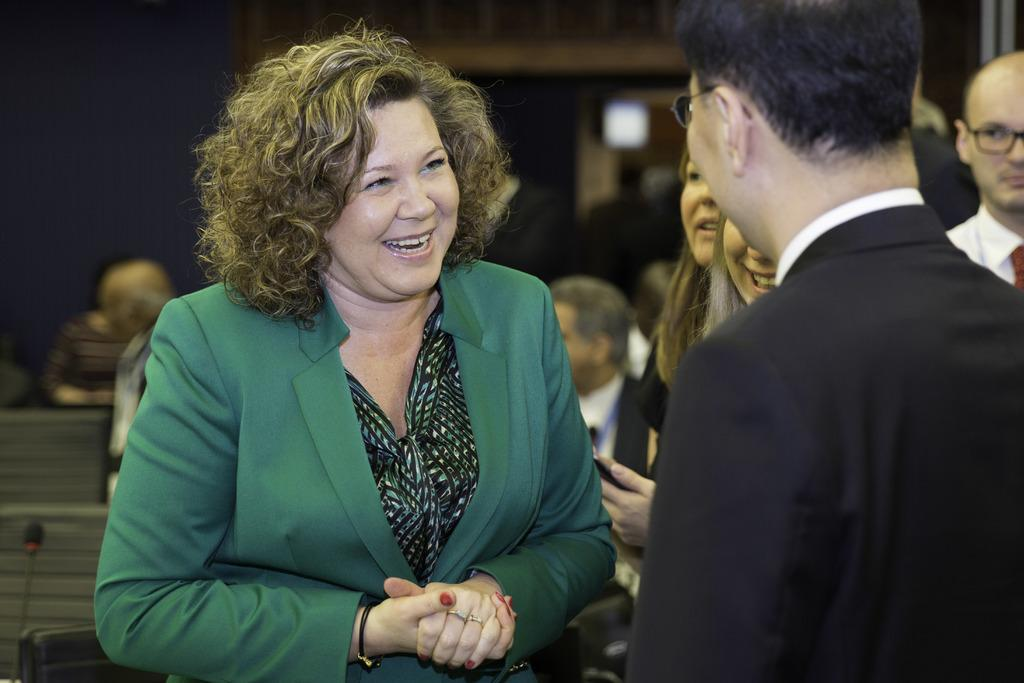How many people are in the image? There are a few people in the image. What object can be seen in the image that is typically used for amplifying sound? There is a microphone in the image. What is located at the bottom of the image? There is an object at the bottom of the image. Can you describe the background of the image? The background of the image is blurred. What type of songs can be heard being sung by the people in the image? There is no indication in the image that the people are singing or that any songs are being played. What type of fork is visible in the image? There is no fork present in the image. 